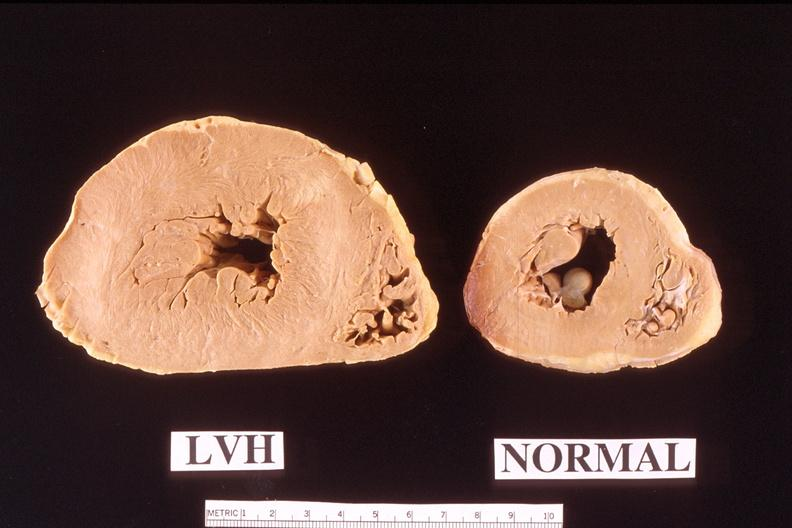how is heart left hypertrophy compared to normal heart?
Answer the question using a single word or phrase. Ventricular 